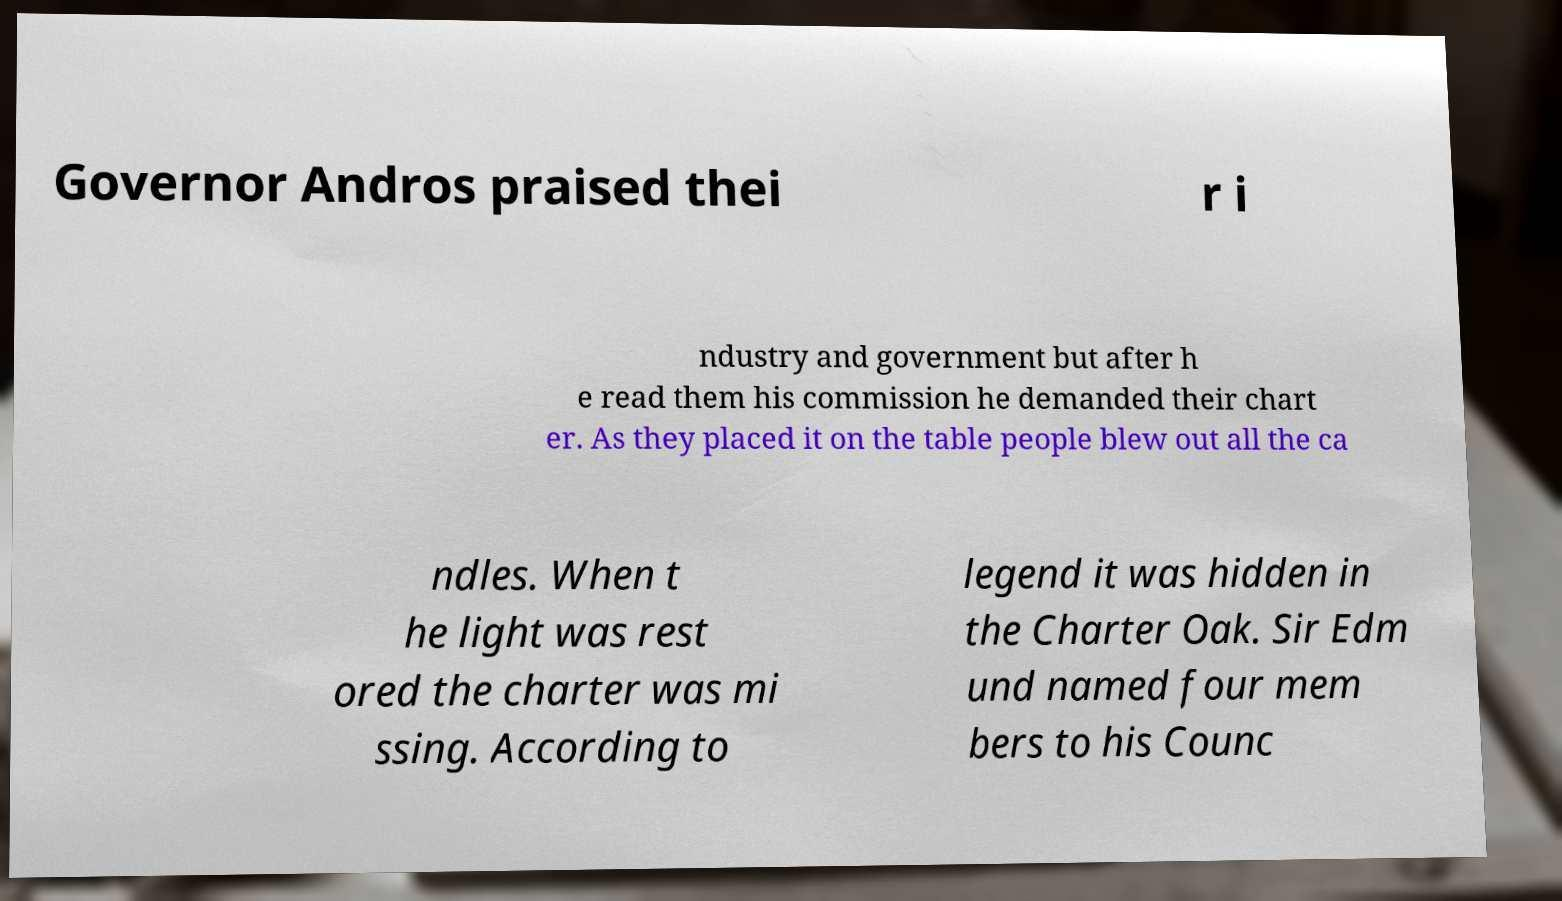Can you accurately transcribe the text from the provided image for me? Governor Andros praised thei r i ndustry and government but after h e read them his commission he demanded their chart er. As they placed it on the table people blew out all the ca ndles. When t he light was rest ored the charter was mi ssing. According to legend it was hidden in the Charter Oak. Sir Edm und named four mem bers to his Counc 